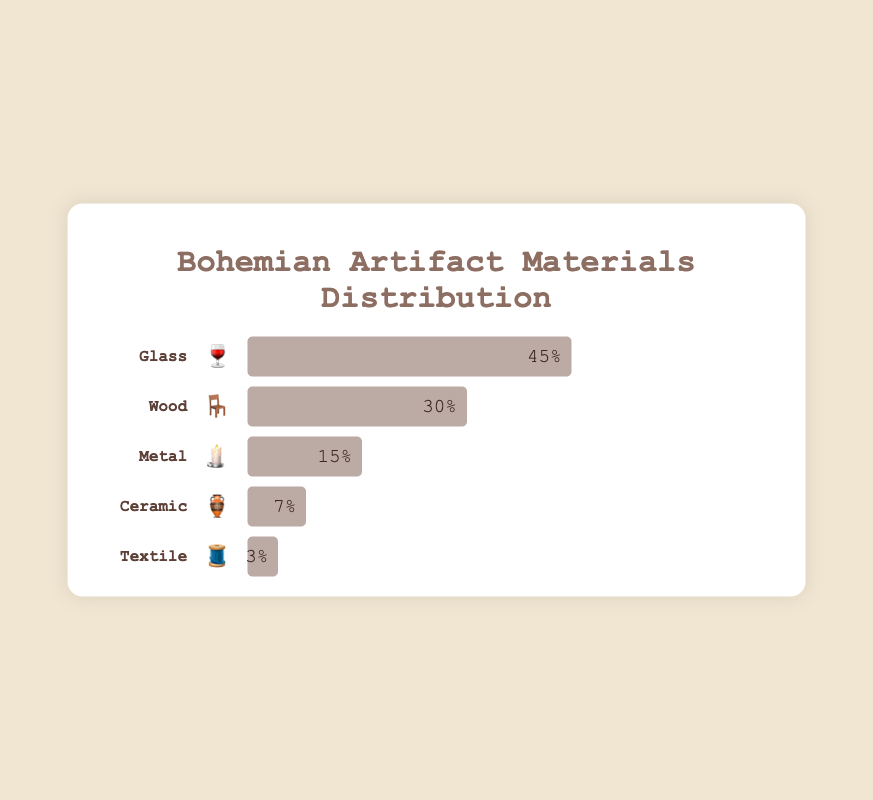What's the most commonly used material in Bohemian artifacts? By looking at the lengths of the bars, the "Glass" bar is the longest, representing the highest percentage.
Answer: Glass Which material is least represented in private collections? The shortest bar represents the material with the lowest percentage. "Textile" has the shortest bar.
Answer: Textile How much more common is glass material compared to metal in these collections? From the chart, glass is 45% and metal is 15%. The difference is 45% - 15%.
Answer: 30% What percentage of the artifacts are made from ceramic and textile combined? Ceramic is 7% and textile is 3%. Their combined percentage is 7% + 3%.
Answer: 10% If wood and metal artifacts make up 45% of the total, what percentage remains for the other materials? Wood is 30% and metal is 15%, summing to 45%. The total is 100%, so the remaining percentage is 100% - 45%.
Answer: 55% Which two materials, when combined, have exactly the same percentage as glass? The glass percentage is 45%. Wood (30%) and metal (15%) sum to 45%, matching glass.
Answer: Wood and Metal Arrange the materials in descending order of their representation. Observing the bar lengths: Glass, Wood, Metal, Ceramic, Textile.
Answer: Glass, Wood, Metal, Ceramic, Textile What fraction of the artifacts are made of wood relative to ceramic? Wood is 30% and ceramic is 7%. The fraction is 30%/7%.
Answer: \( \frac{30}{7} \) or approximately 4.29 